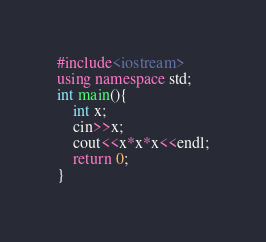<code> <loc_0><loc_0><loc_500><loc_500><_C++_>#include<iostream>
using namespace std;
int main(){
    int x;
    cin>>x;
    cout<<x*x*x<<endl;
    return 0;
}
</code> 